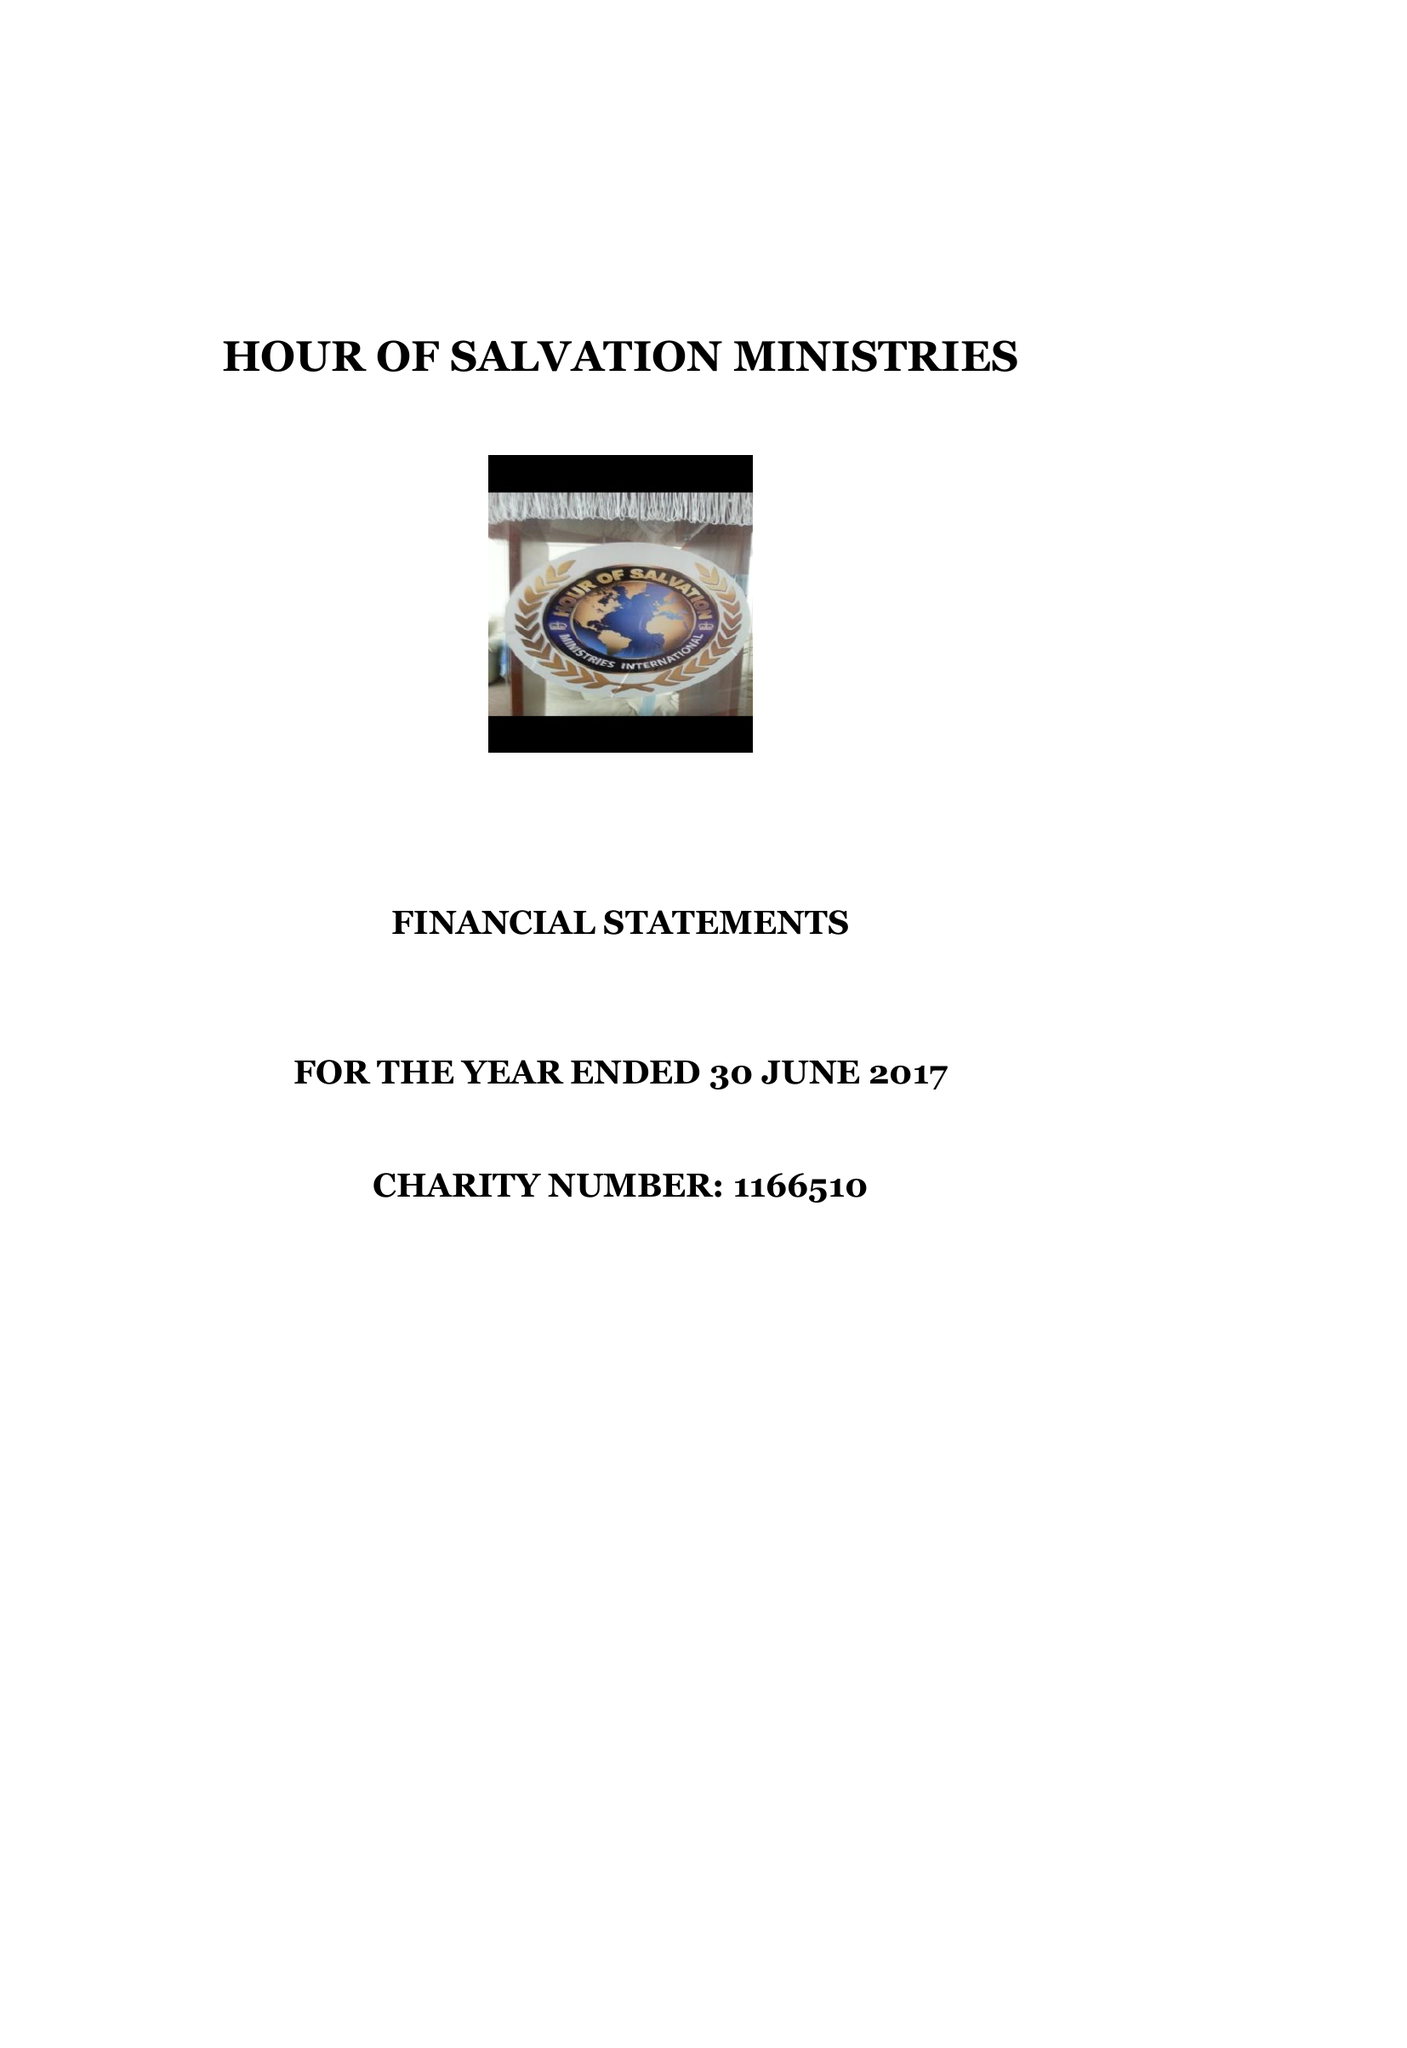What is the value for the charity_number?
Answer the question using a single word or phrase. 1166510 